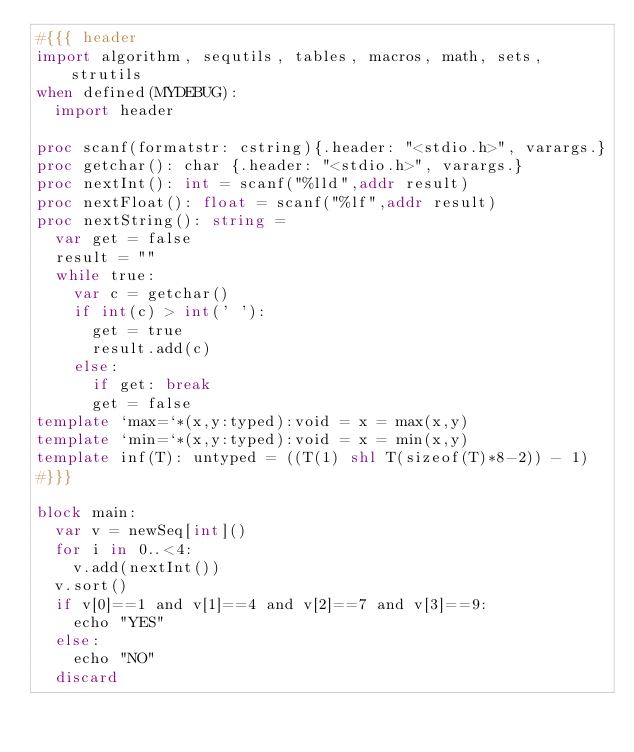<code> <loc_0><loc_0><loc_500><loc_500><_Nim_>#{{{ header
import algorithm, sequtils, tables, macros, math, sets, strutils
when defined(MYDEBUG):
  import header

proc scanf(formatstr: cstring){.header: "<stdio.h>", varargs.}
proc getchar(): char {.header: "<stdio.h>", varargs.}
proc nextInt(): int = scanf("%lld",addr result)
proc nextFloat(): float = scanf("%lf",addr result)
proc nextString(): string =
  var get = false
  result = ""
  while true:
    var c = getchar()
    if int(c) > int(' '):
      get = true
      result.add(c)
    else:
      if get: break
      get = false
template `max=`*(x,y:typed):void = x = max(x,y)
template `min=`*(x,y:typed):void = x = min(x,y)
template inf(T): untyped = ((T(1) shl T(sizeof(T)*8-2)) - 1)
#}}}

block main:
  var v = newSeq[int]()
  for i in 0..<4:
    v.add(nextInt())
  v.sort()
  if v[0]==1 and v[1]==4 and v[2]==7 and v[3]==9:
    echo "YES"
  else:
    echo "NO"
  discard

</code> 